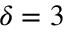<formula> <loc_0><loc_0><loc_500><loc_500>\delta = 3</formula> 